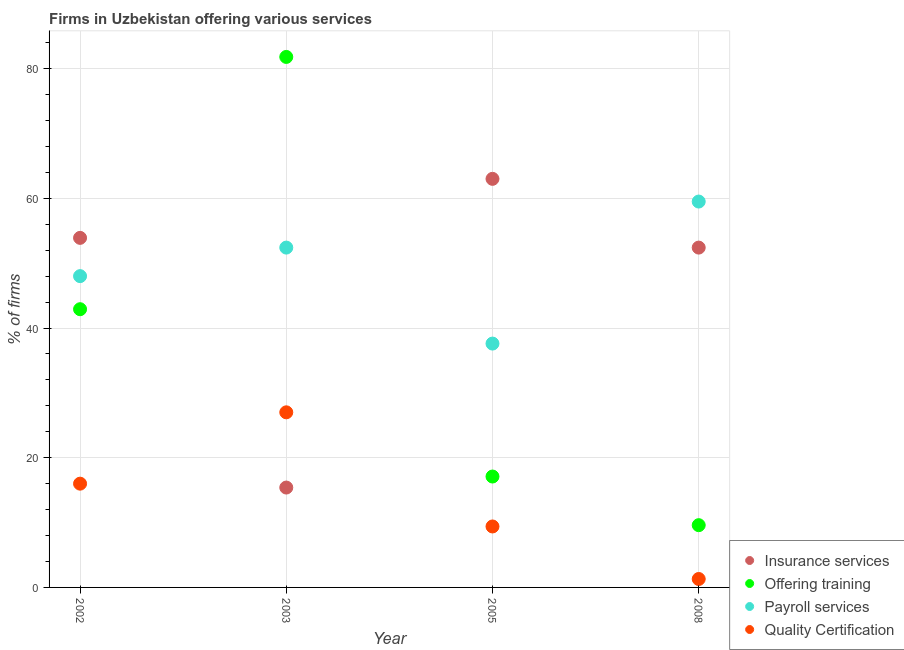How many different coloured dotlines are there?
Offer a very short reply. 4. What is the percentage of firms offering training in 2005?
Your answer should be compact. 17.1. Across all years, what is the maximum percentage of firms offering payroll services?
Ensure brevity in your answer.  59.5. Across all years, what is the minimum percentage of firms offering training?
Ensure brevity in your answer.  9.6. In which year was the percentage of firms offering insurance services minimum?
Provide a short and direct response. 2003. What is the total percentage of firms offering insurance services in the graph?
Make the answer very short. 184.7. What is the difference between the percentage of firms offering payroll services in 2002 and the percentage of firms offering training in 2005?
Offer a terse response. 30.9. What is the average percentage of firms offering payroll services per year?
Offer a terse response. 49.38. In the year 2003, what is the difference between the percentage of firms offering payroll services and percentage of firms offering training?
Make the answer very short. -29.4. In how many years, is the percentage of firms offering payroll services greater than 48 %?
Provide a short and direct response. 2. What is the ratio of the percentage of firms offering insurance services in 2005 to that in 2008?
Your response must be concise. 1.2. Is the difference between the percentage of firms offering insurance services in 2002 and 2005 greater than the difference between the percentage of firms offering quality certification in 2002 and 2005?
Offer a very short reply. No. What is the difference between the highest and the second highest percentage of firms offering training?
Your response must be concise. 38.9. What is the difference between the highest and the lowest percentage of firms offering payroll services?
Offer a terse response. 21.9. In how many years, is the percentage of firms offering payroll services greater than the average percentage of firms offering payroll services taken over all years?
Provide a short and direct response. 2. Is the sum of the percentage of firms offering training in 2003 and 2005 greater than the maximum percentage of firms offering insurance services across all years?
Your answer should be very brief. Yes. Is the percentage of firms offering insurance services strictly greater than the percentage of firms offering quality certification over the years?
Offer a very short reply. No. Are the values on the major ticks of Y-axis written in scientific E-notation?
Ensure brevity in your answer.  No. Does the graph contain grids?
Your answer should be compact. Yes. What is the title of the graph?
Ensure brevity in your answer.  Firms in Uzbekistan offering various services . Does "Corruption" appear as one of the legend labels in the graph?
Make the answer very short. No. What is the label or title of the Y-axis?
Offer a terse response. % of firms. What is the % of firms in Insurance services in 2002?
Your response must be concise. 53.9. What is the % of firms in Offering training in 2002?
Offer a very short reply. 42.9. What is the % of firms in Payroll services in 2002?
Offer a very short reply. 48. What is the % of firms in Offering training in 2003?
Your answer should be compact. 81.8. What is the % of firms in Payroll services in 2003?
Give a very brief answer. 52.4. What is the % of firms of Quality Certification in 2003?
Keep it short and to the point. 27. What is the % of firms in Offering training in 2005?
Your answer should be compact. 17.1. What is the % of firms in Payroll services in 2005?
Offer a terse response. 37.6. What is the % of firms in Quality Certification in 2005?
Offer a very short reply. 9.4. What is the % of firms of Insurance services in 2008?
Offer a very short reply. 52.4. What is the % of firms in Payroll services in 2008?
Your response must be concise. 59.5. Across all years, what is the maximum % of firms of Offering training?
Offer a terse response. 81.8. Across all years, what is the maximum % of firms in Payroll services?
Your answer should be compact. 59.5. Across all years, what is the minimum % of firms of Insurance services?
Provide a short and direct response. 15.4. Across all years, what is the minimum % of firms of Offering training?
Your response must be concise. 9.6. Across all years, what is the minimum % of firms in Payroll services?
Provide a succinct answer. 37.6. Across all years, what is the minimum % of firms of Quality Certification?
Give a very brief answer. 1.3. What is the total % of firms of Insurance services in the graph?
Provide a succinct answer. 184.7. What is the total % of firms of Offering training in the graph?
Provide a short and direct response. 151.4. What is the total % of firms of Payroll services in the graph?
Provide a short and direct response. 197.5. What is the total % of firms of Quality Certification in the graph?
Offer a very short reply. 53.7. What is the difference between the % of firms in Insurance services in 2002 and that in 2003?
Offer a terse response. 38.5. What is the difference between the % of firms in Offering training in 2002 and that in 2003?
Provide a succinct answer. -38.9. What is the difference between the % of firms of Payroll services in 2002 and that in 2003?
Provide a short and direct response. -4.4. What is the difference between the % of firms in Quality Certification in 2002 and that in 2003?
Your response must be concise. -11. What is the difference between the % of firms of Offering training in 2002 and that in 2005?
Make the answer very short. 25.8. What is the difference between the % of firms of Payroll services in 2002 and that in 2005?
Keep it short and to the point. 10.4. What is the difference between the % of firms of Offering training in 2002 and that in 2008?
Give a very brief answer. 33.3. What is the difference between the % of firms in Payroll services in 2002 and that in 2008?
Offer a terse response. -11.5. What is the difference between the % of firms in Insurance services in 2003 and that in 2005?
Make the answer very short. -47.6. What is the difference between the % of firms of Offering training in 2003 and that in 2005?
Ensure brevity in your answer.  64.7. What is the difference between the % of firms of Payroll services in 2003 and that in 2005?
Ensure brevity in your answer.  14.8. What is the difference between the % of firms of Quality Certification in 2003 and that in 2005?
Provide a succinct answer. 17.6. What is the difference between the % of firms in Insurance services in 2003 and that in 2008?
Ensure brevity in your answer.  -37. What is the difference between the % of firms in Offering training in 2003 and that in 2008?
Make the answer very short. 72.2. What is the difference between the % of firms in Payroll services in 2003 and that in 2008?
Your answer should be very brief. -7.1. What is the difference between the % of firms of Quality Certification in 2003 and that in 2008?
Ensure brevity in your answer.  25.7. What is the difference between the % of firms of Payroll services in 2005 and that in 2008?
Your answer should be very brief. -21.9. What is the difference between the % of firms in Insurance services in 2002 and the % of firms in Offering training in 2003?
Provide a succinct answer. -27.9. What is the difference between the % of firms of Insurance services in 2002 and the % of firms of Quality Certification in 2003?
Your answer should be compact. 26.9. What is the difference between the % of firms of Offering training in 2002 and the % of firms of Quality Certification in 2003?
Your answer should be compact. 15.9. What is the difference between the % of firms in Insurance services in 2002 and the % of firms in Offering training in 2005?
Provide a short and direct response. 36.8. What is the difference between the % of firms in Insurance services in 2002 and the % of firms in Quality Certification in 2005?
Offer a terse response. 44.5. What is the difference between the % of firms in Offering training in 2002 and the % of firms in Quality Certification in 2005?
Your answer should be very brief. 33.5. What is the difference between the % of firms in Payroll services in 2002 and the % of firms in Quality Certification in 2005?
Make the answer very short. 38.6. What is the difference between the % of firms in Insurance services in 2002 and the % of firms in Offering training in 2008?
Make the answer very short. 44.3. What is the difference between the % of firms of Insurance services in 2002 and the % of firms of Payroll services in 2008?
Ensure brevity in your answer.  -5.6. What is the difference between the % of firms of Insurance services in 2002 and the % of firms of Quality Certification in 2008?
Keep it short and to the point. 52.6. What is the difference between the % of firms in Offering training in 2002 and the % of firms in Payroll services in 2008?
Ensure brevity in your answer.  -16.6. What is the difference between the % of firms in Offering training in 2002 and the % of firms in Quality Certification in 2008?
Offer a terse response. 41.6. What is the difference between the % of firms of Payroll services in 2002 and the % of firms of Quality Certification in 2008?
Ensure brevity in your answer.  46.7. What is the difference between the % of firms of Insurance services in 2003 and the % of firms of Offering training in 2005?
Provide a short and direct response. -1.7. What is the difference between the % of firms of Insurance services in 2003 and the % of firms of Payroll services in 2005?
Your answer should be compact. -22.2. What is the difference between the % of firms in Offering training in 2003 and the % of firms in Payroll services in 2005?
Your answer should be compact. 44.2. What is the difference between the % of firms in Offering training in 2003 and the % of firms in Quality Certification in 2005?
Keep it short and to the point. 72.4. What is the difference between the % of firms in Payroll services in 2003 and the % of firms in Quality Certification in 2005?
Your response must be concise. 43. What is the difference between the % of firms of Insurance services in 2003 and the % of firms of Offering training in 2008?
Your answer should be very brief. 5.8. What is the difference between the % of firms of Insurance services in 2003 and the % of firms of Payroll services in 2008?
Keep it short and to the point. -44.1. What is the difference between the % of firms in Offering training in 2003 and the % of firms in Payroll services in 2008?
Give a very brief answer. 22.3. What is the difference between the % of firms of Offering training in 2003 and the % of firms of Quality Certification in 2008?
Offer a very short reply. 80.5. What is the difference between the % of firms in Payroll services in 2003 and the % of firms in Quality Certification in 2008?
Make the answer very short. 51.1. What is the difference between the % of firms in Insurance services in 2005 and the % of firms in Offering training in 2008?
Your answer should be very brief. 53.4. What is the difference between the % of firms of Insurance services in 2005 and the % of firms of Quality Certification in 2008?
Give a very brief answer. 61.7. What is the difference between the % of firms of Offering training in 2005 and the % of firms of Payroll services in 2008?
Your answer should be very brief. -42.4. What is the difference between the % of firms of Offering training in 2005 and the % of firms of Quality Certification in 2008?
Keep it short and to the point. 15.8. What is the difference between the % of firms of Payroll services in 2005 and the % of firms of Quality Certification in 2008?
Ensure brevity in your answer.  36.3. What is the average % of firms of Insurance services per year?
Your answer should be compact. 46.17. What is the average % of firms of Offering training per year?
Your response must be concise. 37.85. What is the average % of firms in Payroll services per year?
Your response must be concise. 49.38. What is the average % of firms in Quality Certification per year?
Your answer should be very brief. 13.43. In the year 2002, what is the difference between the % of firms of Insurance services and % of firms of Payroll services?
Provide a short and direct response. 5.9. In the year 2002, what is the difference between the % of firms in Insurance services and % of firms in Quality Certification?
Ensure brevity in your answer.  37.9. In the year 2002, what is the difference between the % of firms of Offering training and % of firms of Payroll services?
Offer a very short reply. -5.1. In the year 2002, what is the difference between the % of firms of Offering training and % of firms of Quality Certification?
Your answer should be compact. 26.9. In the year 2002, what is the difference between the % of firms in Payroll services and % of firms in Quality Certification?
Give a very brief answer. 32. In the year 2003, what is the difference between the % of firms in Insurance services and % of firms in Offering training?
Offer a terse response. -66.4. In the year 2003, what is the difference between the % of firms of Insurance services and % of firms of Payroll services?
Offer a very short reply. -37. In the year 2003, what is the difference between the % of firms of Insurance services and % of firms of Quality Certification?
Your answer should be very brief. -11.6. In the year 2003, what is the difference between the % of firms in Offering training and % of firms in Payroll services?
Your response must be concise. 29.4. In the year 2003, what is the difference between the % of firms in Offering training and % of firms in Quality Certification?
Ensure brevity in your answer.  54.8. In the year 2003, what is the difference between the % of firms of Payroll services and % of firms of Quality Certification?
Provide a succinct answer. 25.4. In the year 2005, what is the difference between the % of firms in Insurance services and % of firms in Offering training?
Your answer should be compact. 45.9. In the year 2005, what is the difference between the % of firms of Insurance services and % of firms of Payroll services?
Provide a short and direct response. 25.4. In the year 2005, what is the difference between the % of firms in Insurance services and % of firms in Quality Certification?
Offer a very short reply. 53.6. In the year 2005, what is the difference between the % of firms in Offering training and % of firms in Payroll services?
Give a very brief answer. -20.5. In the year 2005, what is the difference between the % of firms of Offering training and % of firms of Quality Certification?
Offer a terse response. 7.7. In the year 2005, what is the difference between the % of firms of Payroll services and % of firms of Quality Certification?
Make the answer very short. 28.2. In the year 2008, what is the difference between the % of firms of Insurance services and % of firms of Offering training?
Ensure brevity in your answer.  42.8. In the year 2008, what is the difference between the % of firms in Insurance services and % of firms in Payroll services?
Offer a terse response. -7.1. In the year 2008, what is the difference between the % of firms in Insurance services and % of firms in Quality Certification?
Ensure brevity in your answer.  51.1. In the year 2008, what is the difference between the % of firms of Offering training and % of firms of Payroll services?
Provide a short and direct response. -49.9. In the year 2008, what is the difference between the % of firms in Payroll services and % of firms in Quality Certification?
Make the answer very short. 58.2. What is the ratio of the % of firms of Insurance services in 2002 to that in 2003?
Keep it short and to the point. 3.5. What is the ratio of the % of firms of Offering training in 2002 to that in 2003?
Provide a short and direct response. 0.52. What is the ratio of the % of firms in Payroll services in 2002 to that in 2003?
Keep it short and to the point. 0.92. What is the ratio of the % of firms of Quality Certification in 2002 to that in 2003?
Offer a very short reply. 0.59. What is the ratio of the % of firms of Insurance services in 2002 to that in 2005?
Give a very brief answer. 0.86. What is the ratio of the % of firms in Offering training in 2002 to that in 2005?
Your answer should be very brief. 2.51. What is the ratio of the % of firms of Payroll services in 2002 to that in 2005?
Your response must be concise. 1.28. What is the ratio of the % of firms of Quality Certification in 2002 to that in 2005?
Make the answer very short. 1.7. What is the ratio of the % of firms of Insurance services in 2002 to that in 2008?
Keep it short and to the point. 1.03. What is the ratio of the % of firms in Offering training in 2002 to that in 2008?
Offer a terse response. 4.47. What is the ratio of the % of firms in Payroll services in 2002 to that in 2008?
Your response must be concise. 0.81. What is the ratio of the % of firms of Quality Certification in 2002 to that in 2008?
Offer a very short reply. 12.31. What is the ratio of the % of firms in Insurance services in 2003 to that in 2005?
Provide a short and direct response. 0.24. What is the ratio of the % of firms of Offering training in 2003 to that in 2005?
Provide a short and direct response. 4.78. What is the ratio of the % of firms of Payroll services in 2003 to that in 2005?
Your response must be concise. 1.39. What is the ratio of the % of firms of Quality Certification in 2003 to that in 2005?
Provide a short and direct response. 2.87. What is the ratio of the % of firms in Insurance services in 2003 to that in 2008?
Provide a succinct answer. 0.29. What is the ratio of the % of firms of Offering training in 2003 to that in 2008?
Ensure brevity in your answer.  8.52. What is the ratio of the % of firms in Payroll services in 2003 to that in 2008?
Provide a short and direct response. 0.88. What is the ratio of the % of firms in Quality Certification in 2003 to that in 2008?
Offer a very short reply. 20.77. What is the ratio of the % of firms of Insurance services in 2005 to that in 2008?
Give a very brief answer. 1.2. What is the ratio of the % of firms of Offering training in 2005 to that in 2008?
Offer a terse response. 1.78. What is the ratio of the % of firms of Payroll services in 2005 to that in 2008?
Your response must be concise. 0.63. What is the ratio of the % of firms of Quality Certification in 2005 to that in 2008?
Give a very brief answer. 7.23. What is the difference between the highest and the second highest % of firms in Insurance services?
Ensure brevity in your answer.  9.1. What is the difference between the highest and the second highest % of firms of Offering training?
Offer a very short reply. 38.9. What is the difference between the highest and the second highest % of firms in Payroll services?
Your answer should be compact. 7.1. What is the difference between the highest and the lowest % of firms in Insurance services?
Offer a terse response. 47.6. What is the difference between the highest and the lowest % of firms in Offering training?
Keep it short and to the point. 72.2. What is the difference between the highest and the lowest % of firms of Payroll services?
Your answer should be very brief. 21.9. What is the difference between the highest and the lowest % of firms in Quality Certification?
Keep it short and to the point. 25.7. 